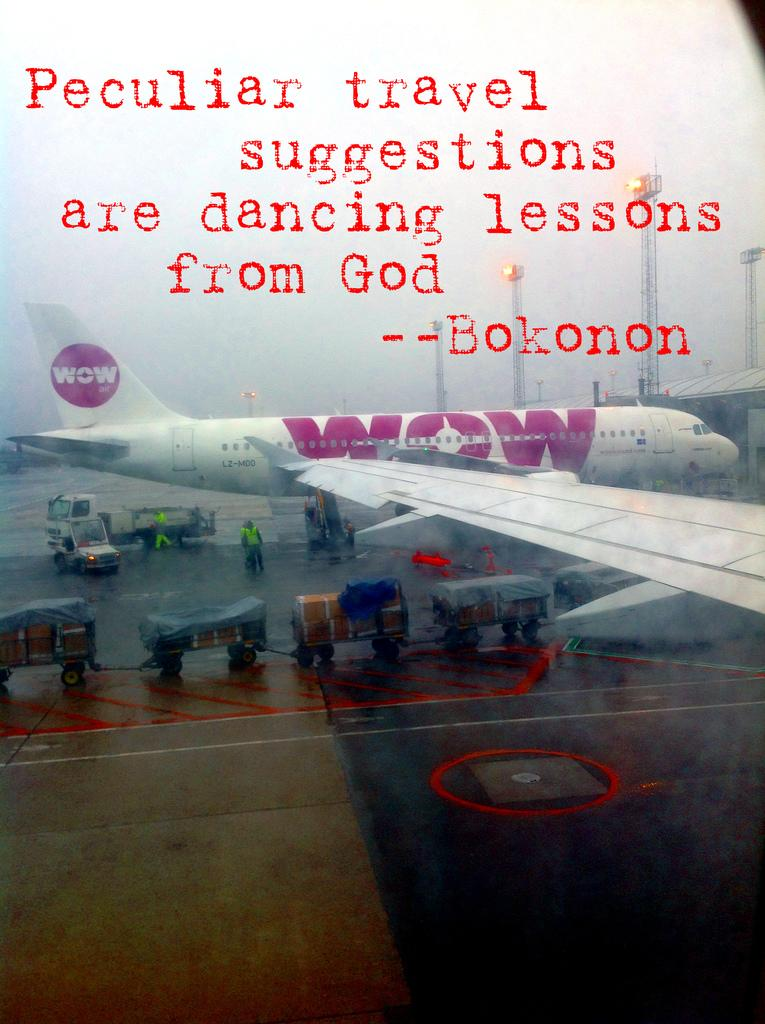<image>
Provide a brief description of the given image. Bokonon has been quoted as saying peculiar travel suggestions are dancing lessons from God. 